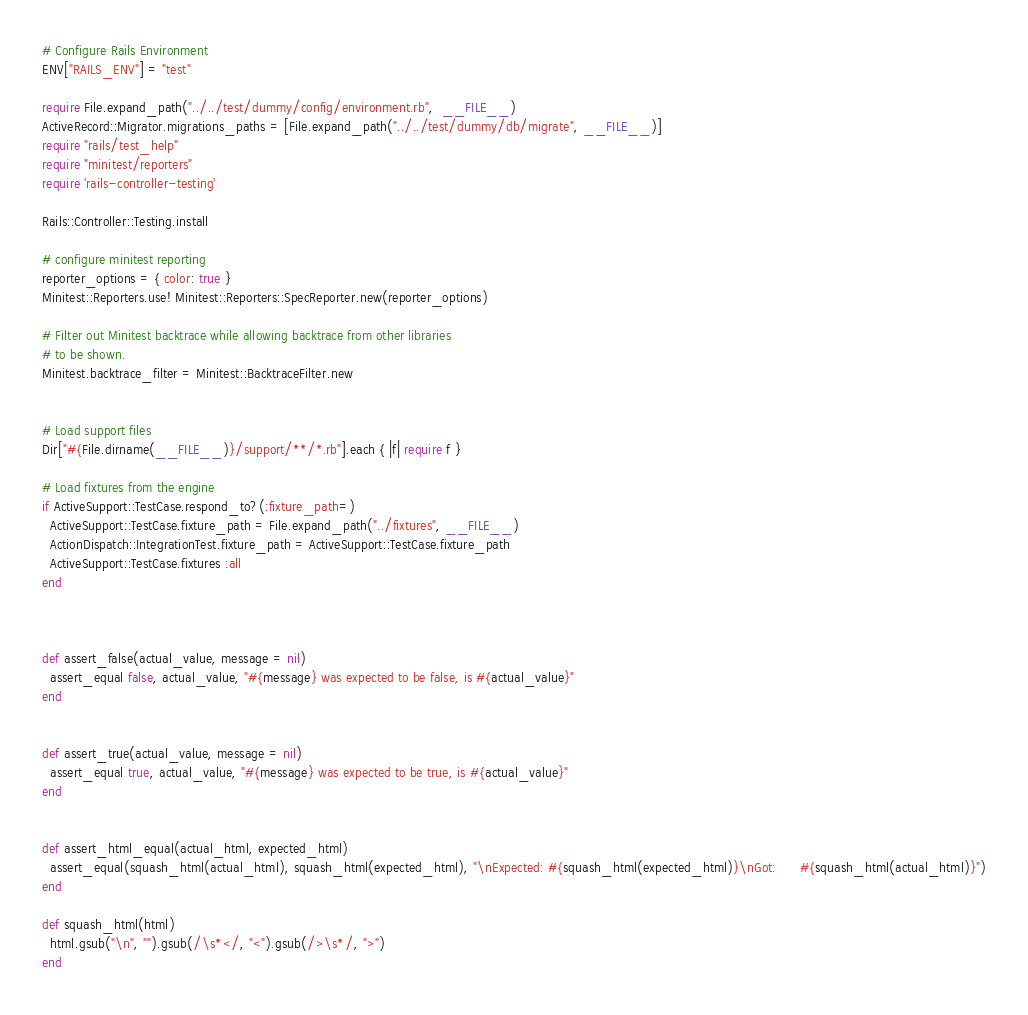<code> <loc_0><loc_0><loc_500><loc_500><_Ruby_># Configure Rails Environment
ENV["RAILS_ENV"] = "test"

require File.expand_path("../../test/dummy/config/environment.rb",  __FILE__)
ActiveRecord::Migrator.migrations_paths = [File.expand_path("../../test/dummy/db/migrate", __FILE__)]
require "rails/test_help"
require "minitest/reporters"
require 'rails-controller-testing'

Rails::Controller::Testing.install

# configure minitest reporting
reporter_options = { color: true }
Minitest::Reporters.use! Minitest::Reporters::SpecReporter.new(reporter_options)

# Filter out Minitest backtrace while allowing backtrace from other libraries
# to be shown.
Minitest.backtrace_filter = Minitest::BacktraceFilter.new


# Load support files
Dir["#{File.dirname(__FILE__)}/support/**/*.rb"].each { |f| require f }

# Load fixtures from the engine
if ActiveSupport::TestCase.respond_to?(:fixture_path=)
  ActiveSupport::TestCase.fixture_path = File.expand_path("../fixtures", __FILE__)
  ActionDispatch::IntegrationTest.fixture_path = ActiveSupport::TestCase.fixture_path
  ActiveSupport::TestCase.fixtures :all
end



def assert_false(actual_value, message = nil)
  assert_equal false, actual_value, "#{message} was expected to be false, is #{actual_value}"
end


def assert_true(actual_value, message = nil)
  assert_equal true, actual_value, "#{message} was expected to be true, is #{actual_value}"
end


def assert_html_equal(actual_html, expected_html)
  assert_equal(squash_html(actual_html), squash_html(expected_html), "\nExpected: #{squash_html(expected_html)}\nGot:      #{squash_html(actual_html)}")
end

def squash_html(html)
  html.gsub("\n", "").gsub(/\s*</, "<").gsub(/>\s*/, ">")
end



</code> 